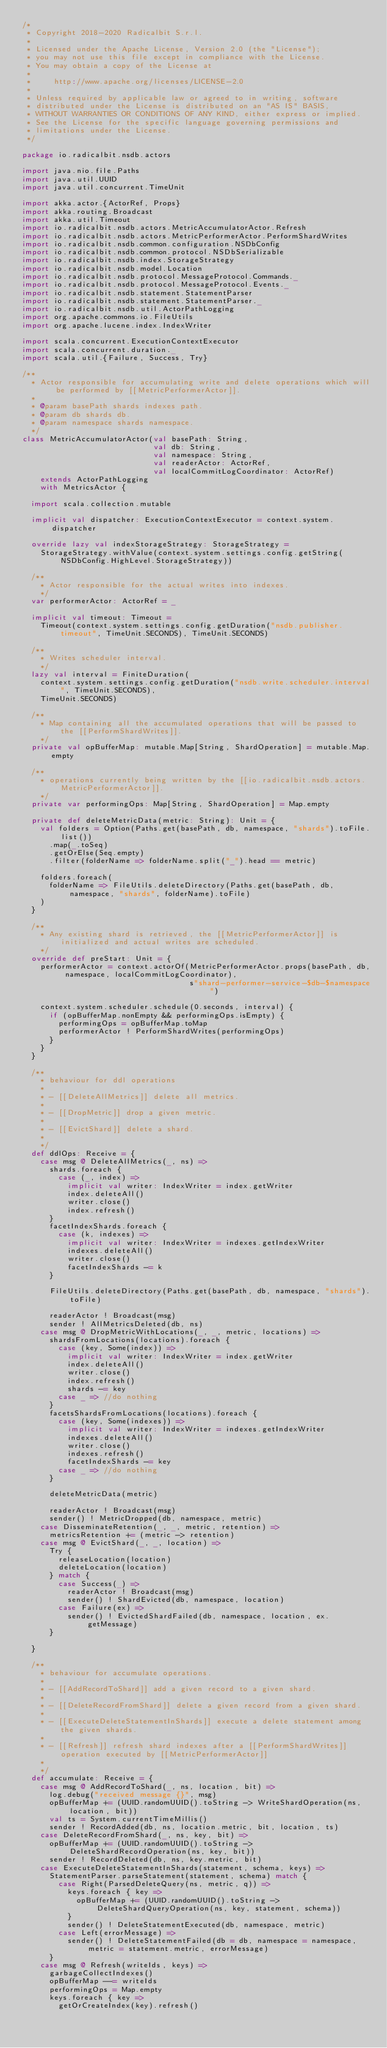Convert code to text. <code><loc_0><loc_0><loc_500><loc_500><_Scala_>/*
 * Copyright 2018-2020 Radicalbit S.r.l.
 *
 * Licensed under the Apache License, Version 2.0 (the "License");
 * you may not use this file except in compliance with the License.
 * You may obtain a copy of the License at
 *
 *     http://www.apache.org/licenses/LICENSE-2.0
 *
 * Unless required by applicable law or agreed to in writing, software
 * distributed under the License is distributed on an "AS IS" BASIS,
 * WITHOUT WARRANTIES OR CONDITIONS OF ANY KIND, either express or implied.
 * See the License for the specific language governing permissions and
 * limitations under the License.
 */

package io.radicalbit.nsdb.actors

import java.nio.file.Paths
import java.util.UUID
import java.util.concurrent.TimeUnit

import akka.actor.{ActorRef, Props}
import akka.routing.Broadcast
import akka.util.Timeout
import io.radicalbit.nsdb.actors.MetricAccumulatorActor.Refresh
import io.radicalbit.nsdb.actors.MetricPerformerActor.PerformShardWrites
import io.radicalbit.nsdb.common.configuration.NSDbConfig
import io.radicalbit.nsdb.common.protocol.NSDbSerializable
import io.radicalbit.nsdb.index.StorageStrategy
import io.radicalbit.nsdb.model.Location
import io.radicalbit.nsdb.protocol.MessageProtocol.Commands._
import io.radicalbit.nsdb.protocol.MessageProtocol.Events._
import io.radicalbit.nsdb.statement.StatementParser
import io.radicalbit.nsdb.statement.StatementParser._
import io.radicalbit.nsdb.util.ActorPathLogging
import org.apache.commons.io.FileUtils
import org.apache.lucene.index.IndexWriter

import scala.concurrent.ExecutionContextExecutor
import scala.concurrent.duration._
import scala.util.{Failure, Success, Try}

/**
  * Actor responsible for accumulating write and delete operations which will be performed by [[MetricPerformerActor]].
  *
  * @param basePath shards indexes path.
  * @param db shards db.
  * @param namespace shards namespace.
  */
class MetricAccumulatorActor(val basePath: String,
                             val db: String,
                             val namespace: String,
                             val readerActor: ActorRef,
                             val localCommitLogCoordinator: ActorRef)
    extends ActorPathLogging
    with MetricsActor {

  import scala.collection.mutable

  implicit val dispatcher: ExecutionContextExecutor = context.system.dispatcher

  override lazy val indexStorageStrategy: StorageStrategy =
    StorageStrategy.withValue(context.system.settings.config.getString(NSDbConfig.HighLevel.StorageStrategy))

  /**
    * Actor responsible for the actual writes into indexes.
    */
  var performerActor: ActorRef = _

  implicit val timeout: Timeout =
    Timeout(context.system.settings.config.getDuration("nsdb.publisher.timeout", TimeUnit.SECONDS), TimeUnit.SECONDS)

  /**
    * Writes scheduler interval.
    */
  lazy val interval = FiniteDuration(
    context.system.settings.config.getDuration("nsdb.write.scheduler.interval", TimeUnit.SECONDS),
    TimeUnit.SECONDS)

  /**
    * Map containing all the accumulated operations that will be passed to the [[PerformShardWrites]].
    */
  private val opBufferMap: mutable.Map[String, ShardOperation] = mutable.Map.empty

  /**
    * operations currently being written by the [[io.radicalbit.nsdb.actors.MetricPerformerActor]].
    */
  private var performingOps: Map[String, ShardOperation] = Map.empty

  private def deleteMetricData(metric: String): Unit = {
    val folders = Option(Paths.get(basePath, db, namespace, "shards").toFile.list())
      .map(_.toSeq)
      .getOrElse(Seq.empty)
      .filter(folderName => folderName.split("_").head == metric)

    folders.foreach(
      folderName => FileUtils.deleteDirectory(Paths.get(basePath, db, namespace, "shards", folderName).toFile)
    )
  }

  /**
    * Any existing shard is retrieved, the [[MetricPerformerActor]] is initialized and actual writes are scheduled.
    */
  override def preStart: Unit = {
    performerActor = context.actorOf(MetricPerformerActor.props(basePath, db, namespace, localCommitLogCoordinator),
                                     s"shard-performer-service-$db-$namespace")

    context.system.scheduler.schedule(0.seconds, interval) {
      if (opBufferMap.nonEmpty && performingOps.isEmpty) {
        performingOps = opBufferMap.toMap
        performerActor ! PerformShardWrites(performingOps)
      }
    }
  }

  /**
    * behaviour for ddl operations
    *
    * - [[DeleteAllMetrics]] delete all metrics.
    *
    * - [[DropMetric]] drop a given metric.
    *
    * - [[EvictShard]] delete a shard.
    *
    */
  def ddlOps: Receive = {
    case msg @ DeleteAllMetrics(_, ns) =>
      shards.foreach {
        case (_, index) =>
          implicit val writer: IndexWriter = index.getWriter
          index.deleteAll()
          writer.close()
          index.refresh()
      }
      facetIndexShards.foreach {
        case (k, indexes) =>
          implicit val writer: IndexWriter = indexes.getIndexWriter
          indexes.deleteAll()
          writer.close()
          facetIndexShards -= k
      }

      FileUtils.deleteDirectory(Paths.get(basePath, db, namespace, "shards").toFile)

      readerActor ! Broadcast(msg)
      sender ! AllMetricsDeleted(db, ns)
    case msg @ DropMetricWithLocations(_, _, metric, locations) =>
      shardsFromLocations(locations).foreach {
        case (key, Some(index)) =>
          implicit val writer: IndexWriter = index.getWriter
          index.deleteAll()
          writer.close()
          index.refresh()
          shards -= key
        case _ => //do nothing
      }
      facetsShardsFromLocations(locations).foreach {
        case (key, Some(indexes)) =>
          implicit val writer: IndexWriter = indexes.getIndexWriter
          indexes.deleteAll()
          writer.close()
          indexes.refresh()
          facetIndexShards -= key
        case _ => //do nothing
      }

      deleteMetricData(metric)

      readerActor ! Broadcast(msg)
      sender() ! MetricDropped(db, namespace, metric)
    case DisseminateRetention(_, _, metric, retention) =>
      metricsRetention += (metric -> retention)
    case msg @ EvictShard(_, _, location) =>
      Try {
        releaseLocation(location)
        deleteLocation(location)
      } match {
        case Success(_) =>
          readerActor ! Broadcast(msg)
          sender() ! ShardEvicted(db, namespace, location)
        case Failure(ex) =>
          sender() ! EvictedShardFailed(db, namespace, location, ex.getMessage)
      }

  }

  /**
    * behaviour for accumulate operations.
    *
    * - [[AddRecordToShard]] add a given record to a given shard.
    *
    * - [[DeleteRecordFromShard]] delete a given record from a given shard.
    *
    * - [[ExecuteDeleteStatementInShards]] execute a delete statement among the given shards.
    *
    * - [[Refresh]] refresh shard indexes after a [[PerformShardWrites]] operation executed by [[MetricPerformerActor]]
    *
    */
  def accumulate: Receive = {
    case msg @ AddRecordToShard(_, ns, location, bit) =>
      log.debug("received message {}", msg)
      opBufferMap += (UUID.randomUUID().toString -> WriteShardOperation(ns, location, bit))
      val ts = System.currentTimeMillis()
      sender ! RecordAdded(db, ns, location.metric, bit, location, ts)
    case DeleteRecordFromShard(_, ns, key, bit) =>
      opBufferMap += (UUID.randomUUID().toString -> DeleteShardRecordOperation(ns, key, bit))
      sender ! RecordDeleted(db, ns, key.metric, bit)
    case ExecuteDeleteStatementInShards(statement, schema, keys) =>
      StatementParser.parseStatement(statement, schema) match {
        case Right(ParsedDeleteQuery(ns, metric, q)) =>
          keys.foreach { key =>
            opBufferMap += (UUID.randomUUID().toString -> DeleteShardQueryOperation(ns, key, statement, schema))
          }
          sender() ! DeleteStatementExecuted(db, namespace, metric)
        case Left(errorMessage) =>
          sender() ! DeleteStatementFailed(db = db, namespace = namespace, metric = statement.metric, errorMessage)
      }
    case msg @ Refresh(writeIds, keys) =>
      garbageCollectIndexes()
      opBufferMap --= writeIds
      performingOps = Map.empty
      keys.foreach { key =>
        getOrCreateIndex(key).refresh()</code> 